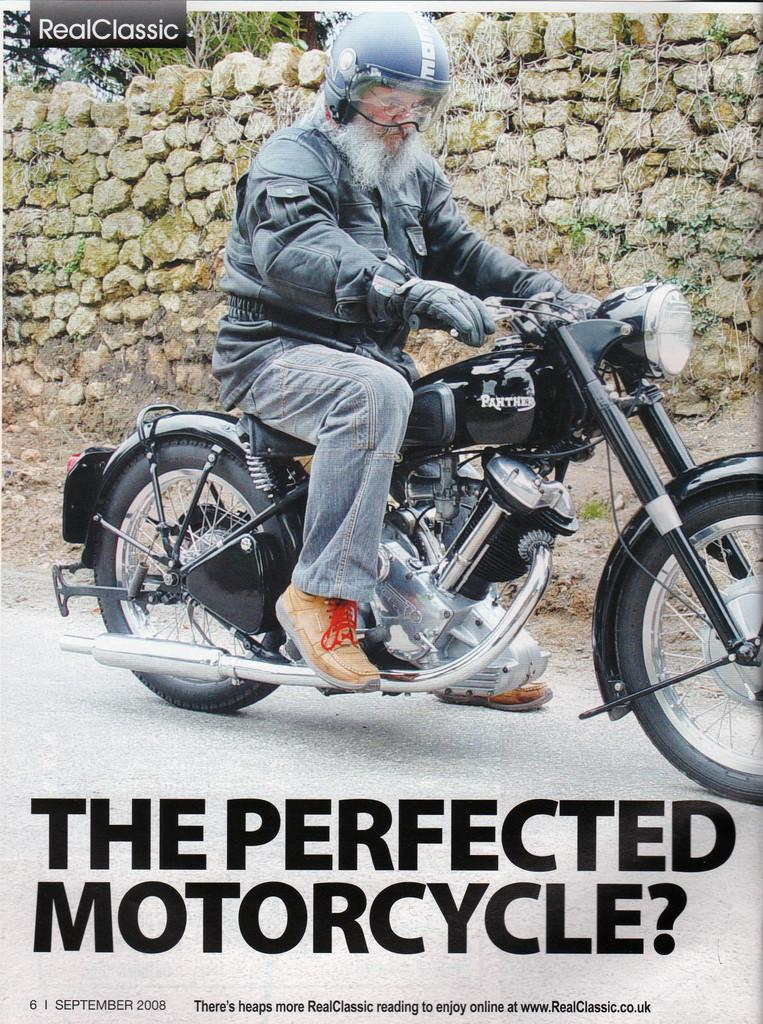What is the man in the image doing? The man is riding a bike in the image. What safety precaution is the man taking while riding the bike? The man is wearing a helmet. What can be seen in the background of the image? The background includes stones, a wall, and a poster. What type of leg is the scarecrow using to ride the bike in the image? There is no scarecrow present in the image, and therefore no such activity can be observed. How many bricks are visible in the image? The provided facts do not mention any bricks in the image. 